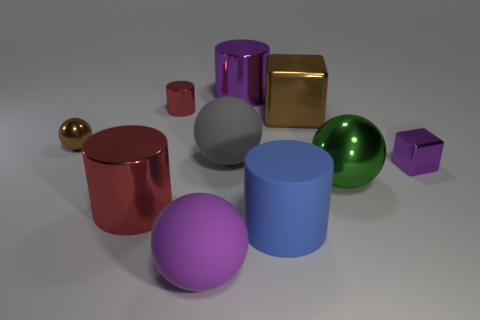Subtract all big balls. How many balls are left? 1 Subtract 2 cylinders. How many cylinders are left? 2 Subtract all purple blocks. How many blocks are left? 1 Subtract all spheres. How many objects are left? 6 Subtract all cyan cylinders. How many purple spheres are left? 1 Subtract all large cyan rubber things. Subtract all purple rubber spheres. How many objects are left? 9 Add 1 big gray balls. How many big gray balls are left? 2 Add 2 small gray cylinders. How many small gray cylinders exist? 2 Subtract 2 red cylinders. How many objects are left? 8 Subtract all green cylinders. Subtract all red balls. How many cylinders are left? 4 